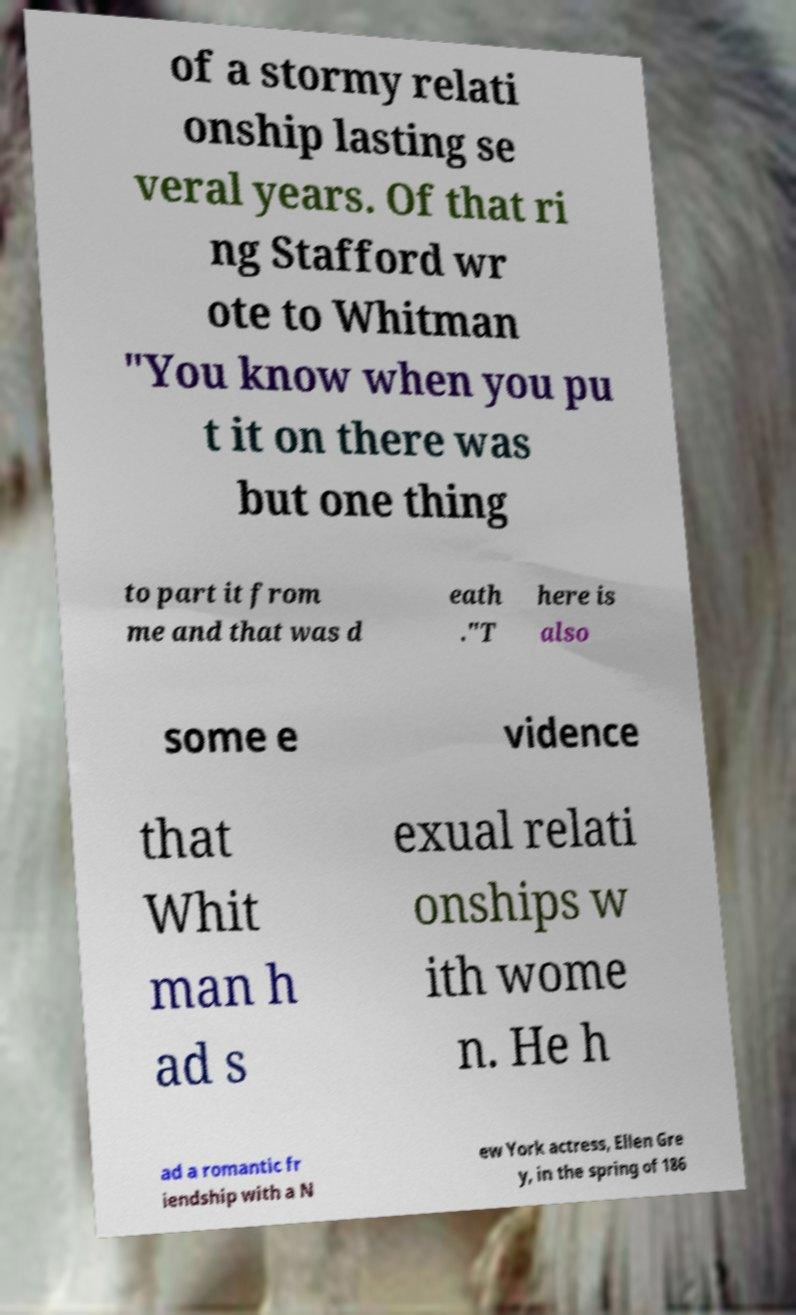Please read and relay the text visible in this image. What does it say? of a stormy relati onship lasting se veral years. Of that ri ng Stafford wr ote to Whitman "You know when you pu t it on there was but one thing to part it from me and that was d eath ."T here is also some e vidence that Whit man h ad s exual relati onships w ith wome n. He h ad a romantic fr iendship with a N ew York actress, Ellen Gre y, in the spring of 186 